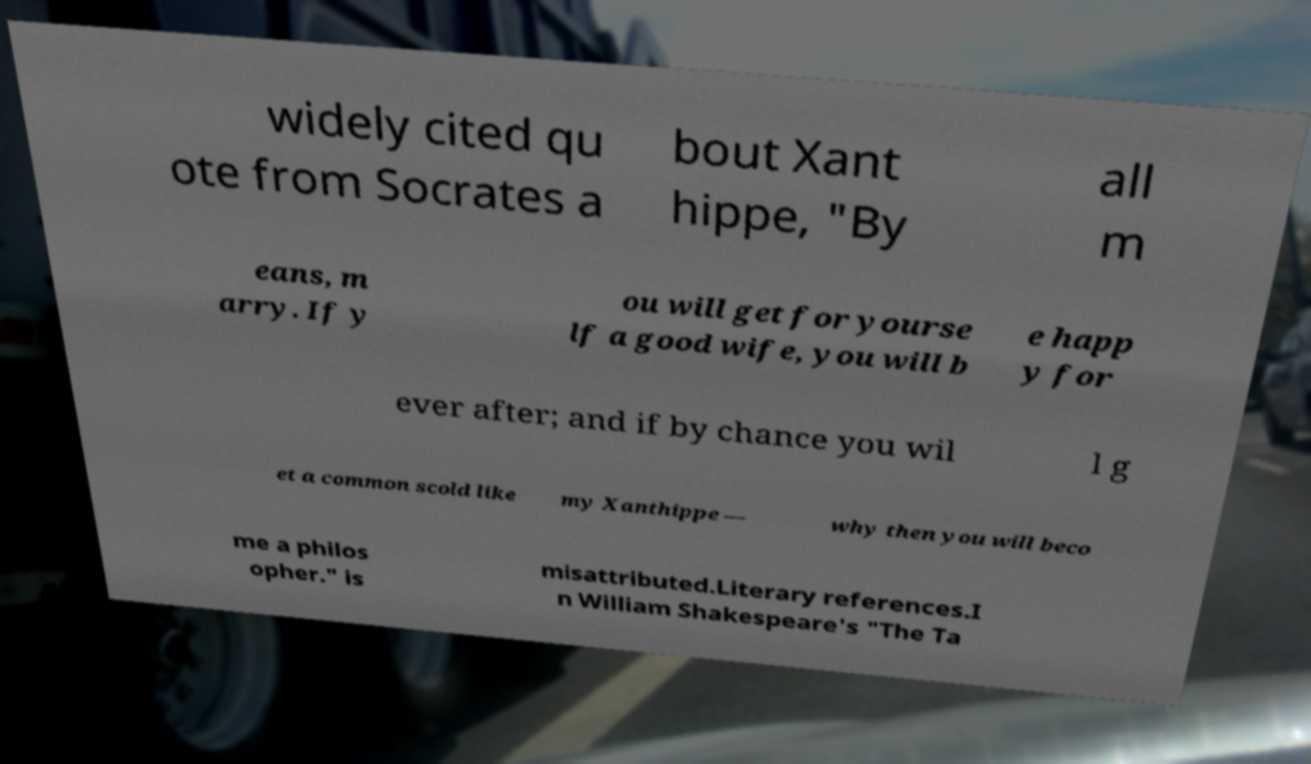Please identify and transcribe the text found in this image. widely cited qu ote from Socrates a bout Xant hippe, "By all m eans, m arry. If y ou will get for yourse lf a good wife, you will b e happ y for ever after; and if by chance you wil l g et a common scold like my Xanthippe — why then you will beco me a philos opher." is misattributed.Literary references.I n William Shakespeare's "The Ta 